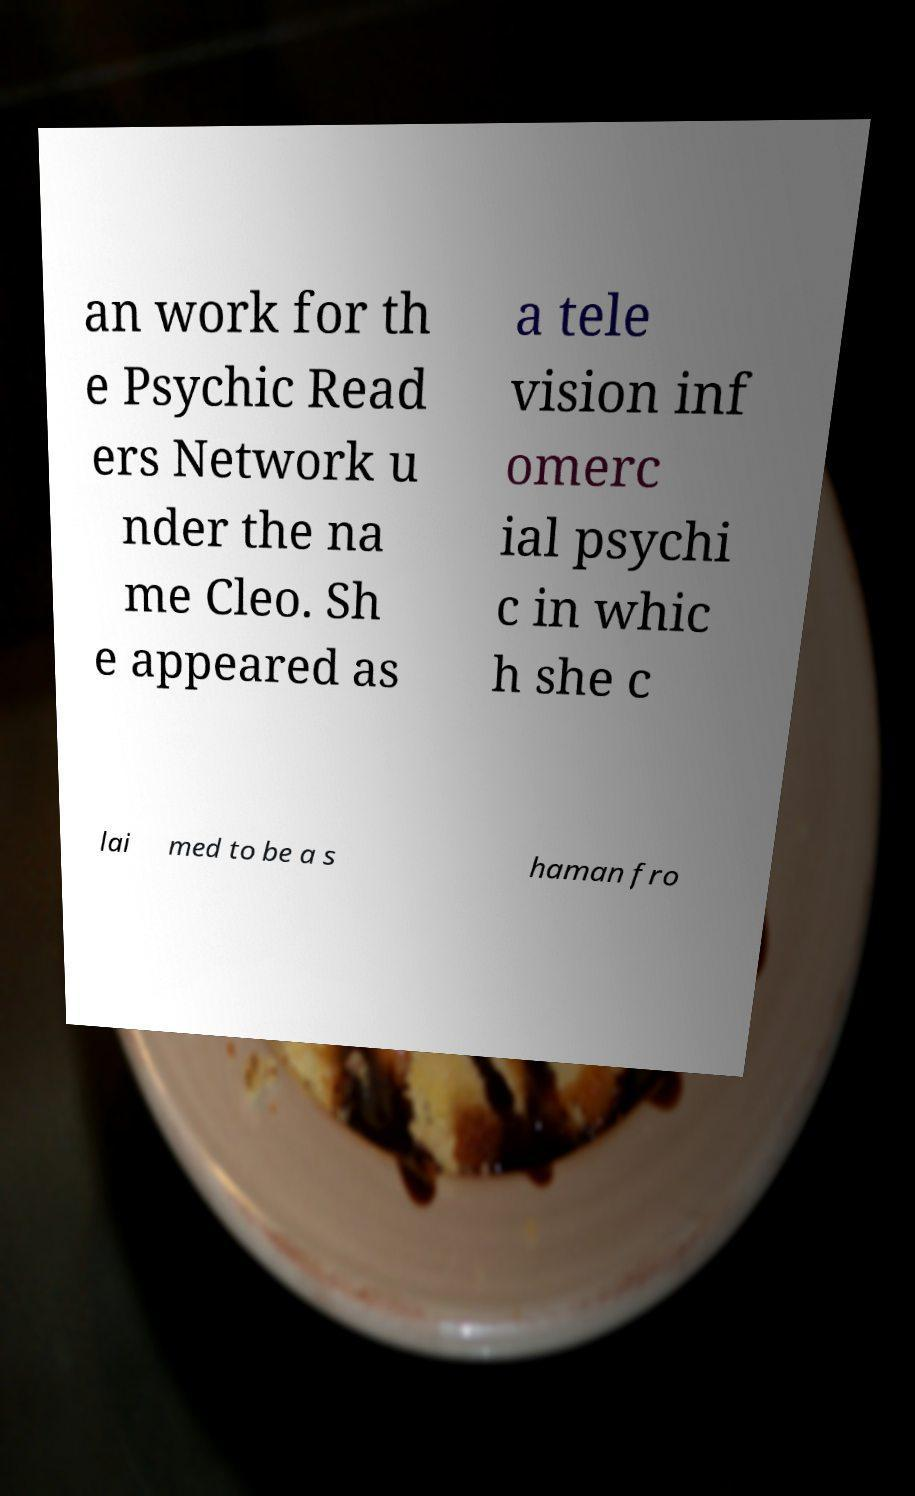There's text embedded in this image that I need extracted. Can you transcribe it verbatim? an work for th e Psychic Read ers Network u nder the na me Cleo. Sh e appeared as a tele vision inf omerc ial psychi c in whic h she c lai med to be a s haman fro 